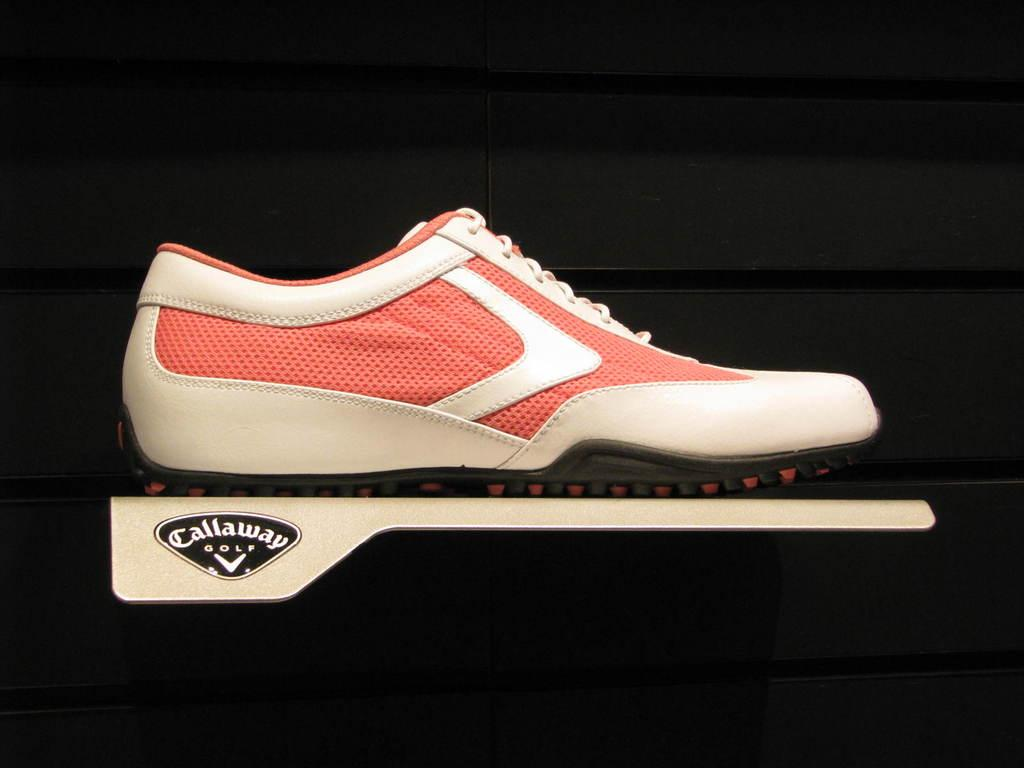What object is the main subject of the image? There is a shoe in the image. What type of surface is the shoe placed on? The shoe is on a metal surface. What color is the background of the image? The background of the image is black. Can you tell me how many women are carrying baskets in the image? There are no women or baskets present in the image; it only features a shoe on a metal surface with a black background. Is there any visible wound on the shoe in the image? There is no visible wound on the shoe in the image. 